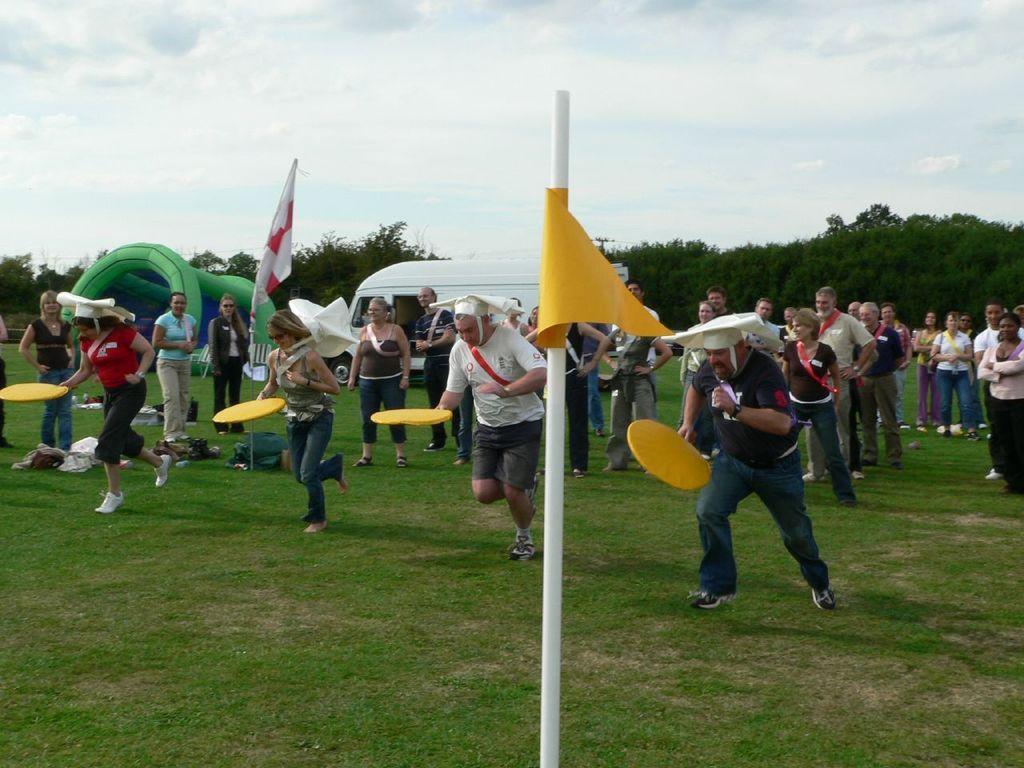Describe this image in one or two sentences. In this image we can see four players with yellow color objects in their hands. In the background we can see some people standing on the grass and watching the players. We can also see the flags. In the background there is a green color object, a vehicle and also many trees. There is sky with the clouds. 